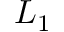<formula> <loc_0><loc_0><loc_500><loc_500>L _ { 1 }</formula> 